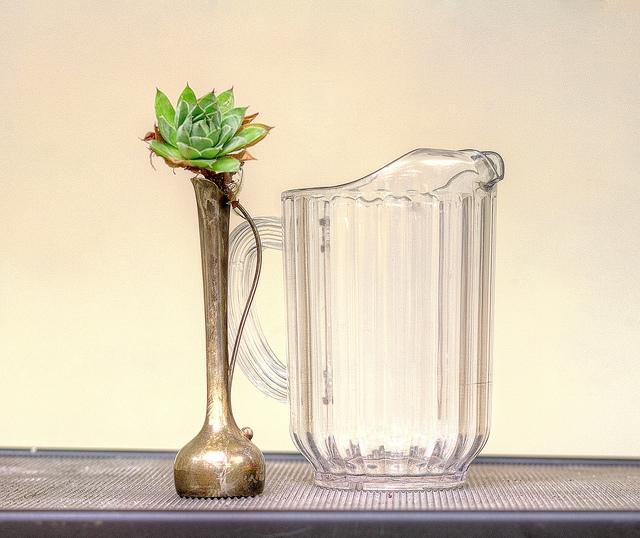What are they showing with this display? Please explain your reasoning. contrast. They are using two polar opposites. 